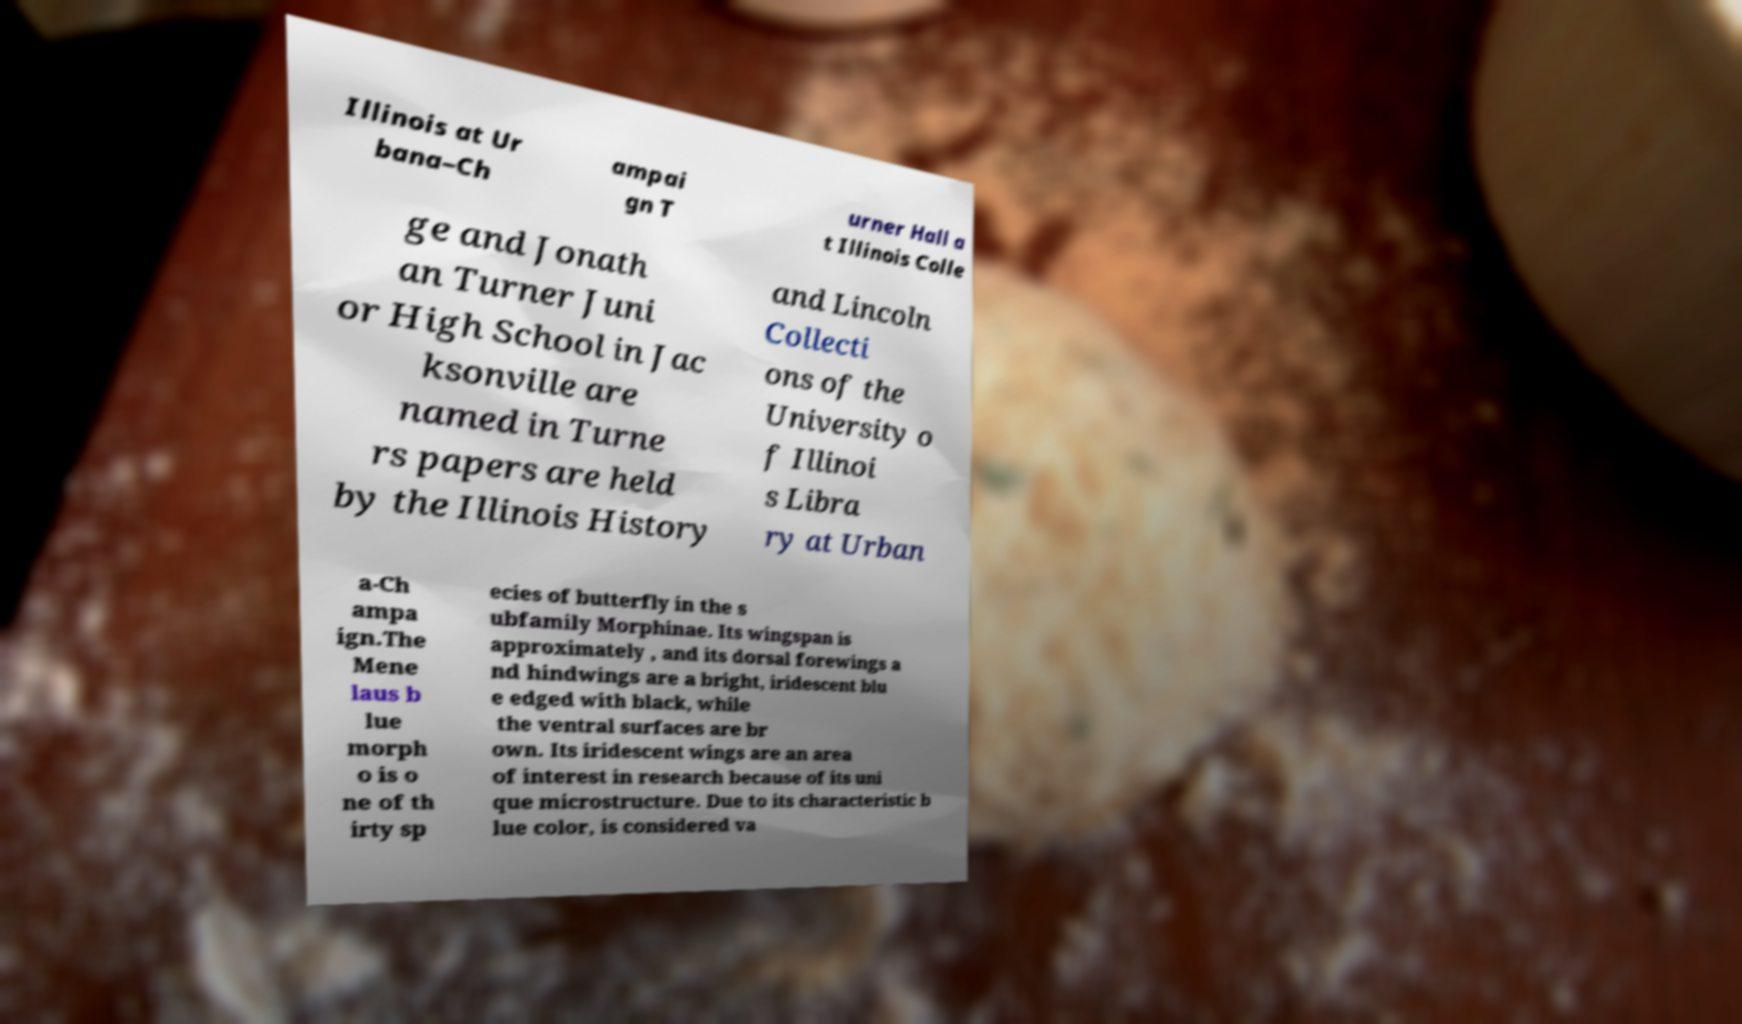Please identify and transcribe the text found in this image. Illinois at Ur bana–Ch ampai gn T urner Hall a t Illinois Colle ge and Jonath an Turner Juni or High School in Jac ksonville are named in Turne rs papers are held by the Illinois History and Lincoln Collecti ons of the University o f Illinoi s Libra ry at Urban a-Ch ampa ign.The Mene laus b lue morph o is o ne of th irty sp ecies of butterfly in the s ubfamily Morphinae. Its wingspan is approximately , and its dorsal forewings a nd hindwings are a bright, iridescent blu e edged with black, while the ventral surfaces are br own. Its iridescent wings are an area of interest in research because of its uni que microstructure. Due to its characteristic b lue color, is considered va 